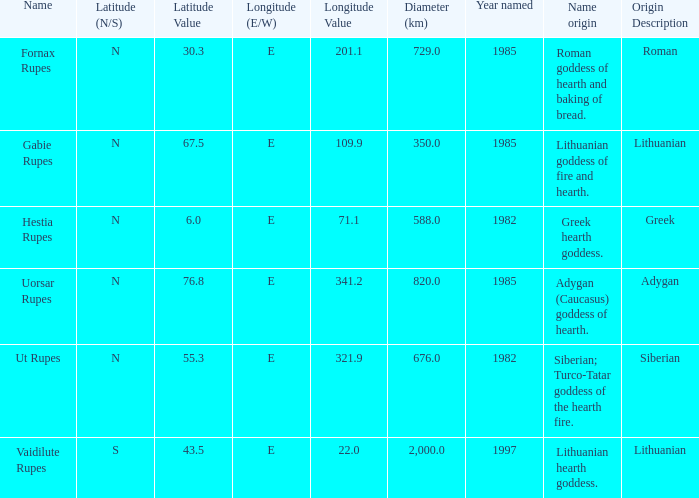What is the latitude of vaidilute rupes? 43.5S. 